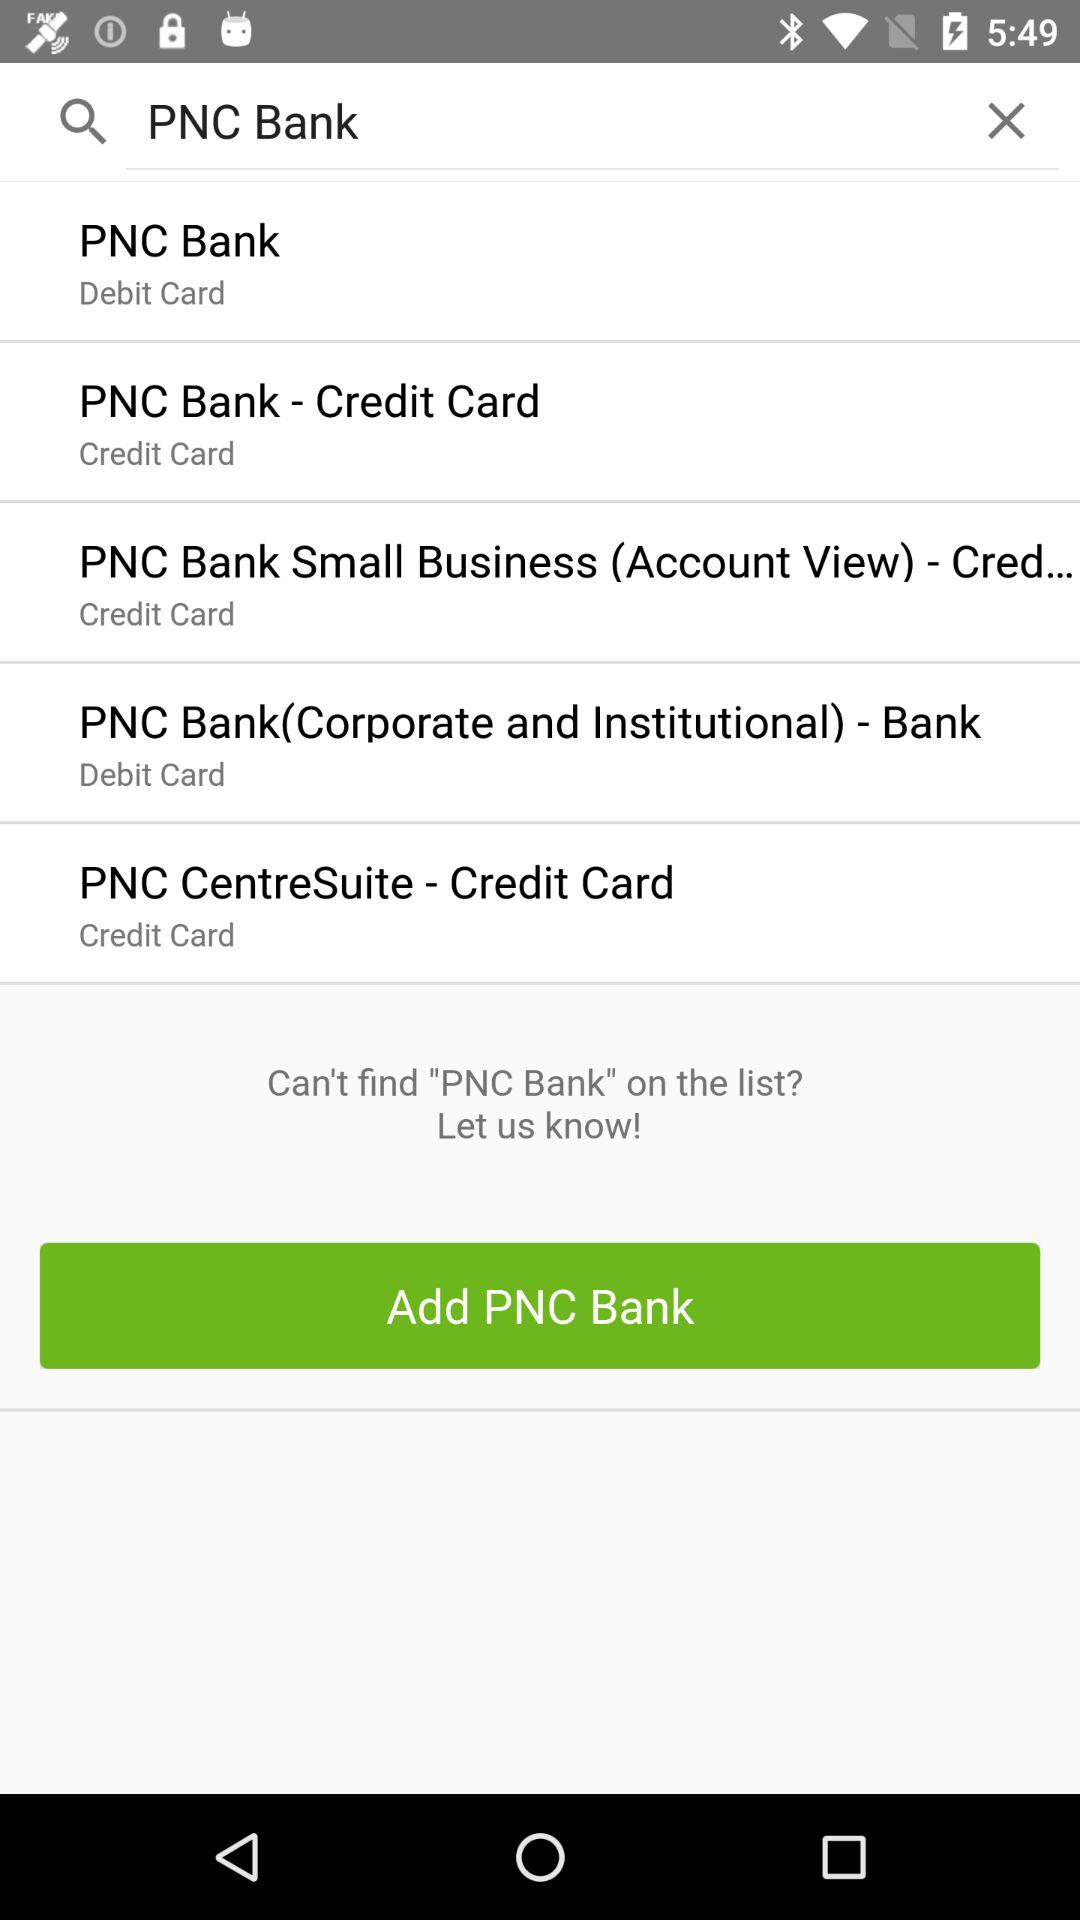How many PNC Bank items are displayed?
Answer the question using a single word or phrase. 5 